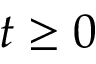Convert formula to latex. <formula><loc_0><loc_0><loc_500><loc_500>t \geq 0</formula> 